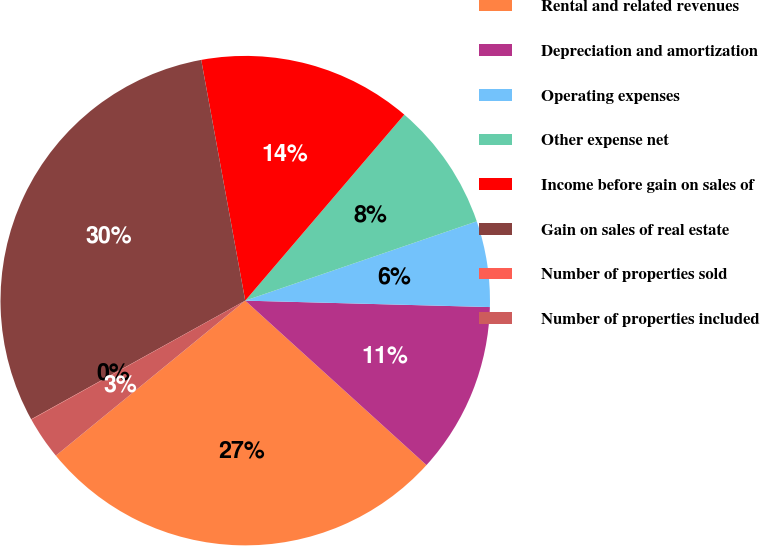Convert chart. <chart><loc_0><loc_0><loc_500><loc_500><pie_chart><fcel>Rental and related revenues<fcel>Depreciation and amortization<fcel>Operating expenses<fcel>Other expense net<fcel>Income before gain on sales of<fcel>Gain on sales of real estate<fcel>Number of properties sold<fcel>Number of properties included<nl><fcel>27.36%<fcel>11.31%<fcel>5.67%<fcel>8.49%<fcel>14.14%<fcel>30.18%<fcel>0.02%<fcel>2.84%<nl></chart> 